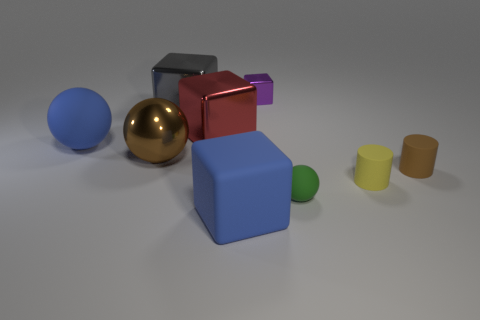Subtract all yellow blocks. Subtract all yellow balls. How many blocks are left? 4 Add 1 big brown cylinders. How many objects exist? 10 Subtract all cylinders. How many objects are left? 7 Subtract all yellow rubber cylinders. Subtract all tiny green shiny blocks. How many objects are left? 8 Add 5 green spheres. How many green spheres are left? 6 Add 9 tiny yellow matte cylinders. How many tiny yellow matte cylinders exist? 10 Subtract 0 gray balls. How many objects are left? 9 